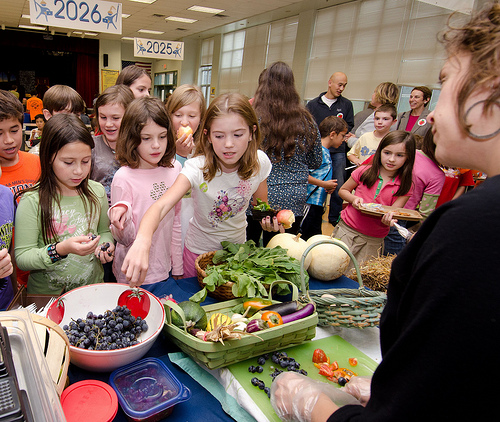<image>
Can you confirm if the fruit is in the basket? No. The fruit is not contained within the basket. These objects have a different spatial relationship. Is there a grapes in front of the girl? No. The grapes is not in front of the girl. The spatial positioning shows a different relationship between these objects. 